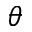Convert formula to latex. <formula><loc_0><loc_0><loc_500><loc_500>\theta</formula> 